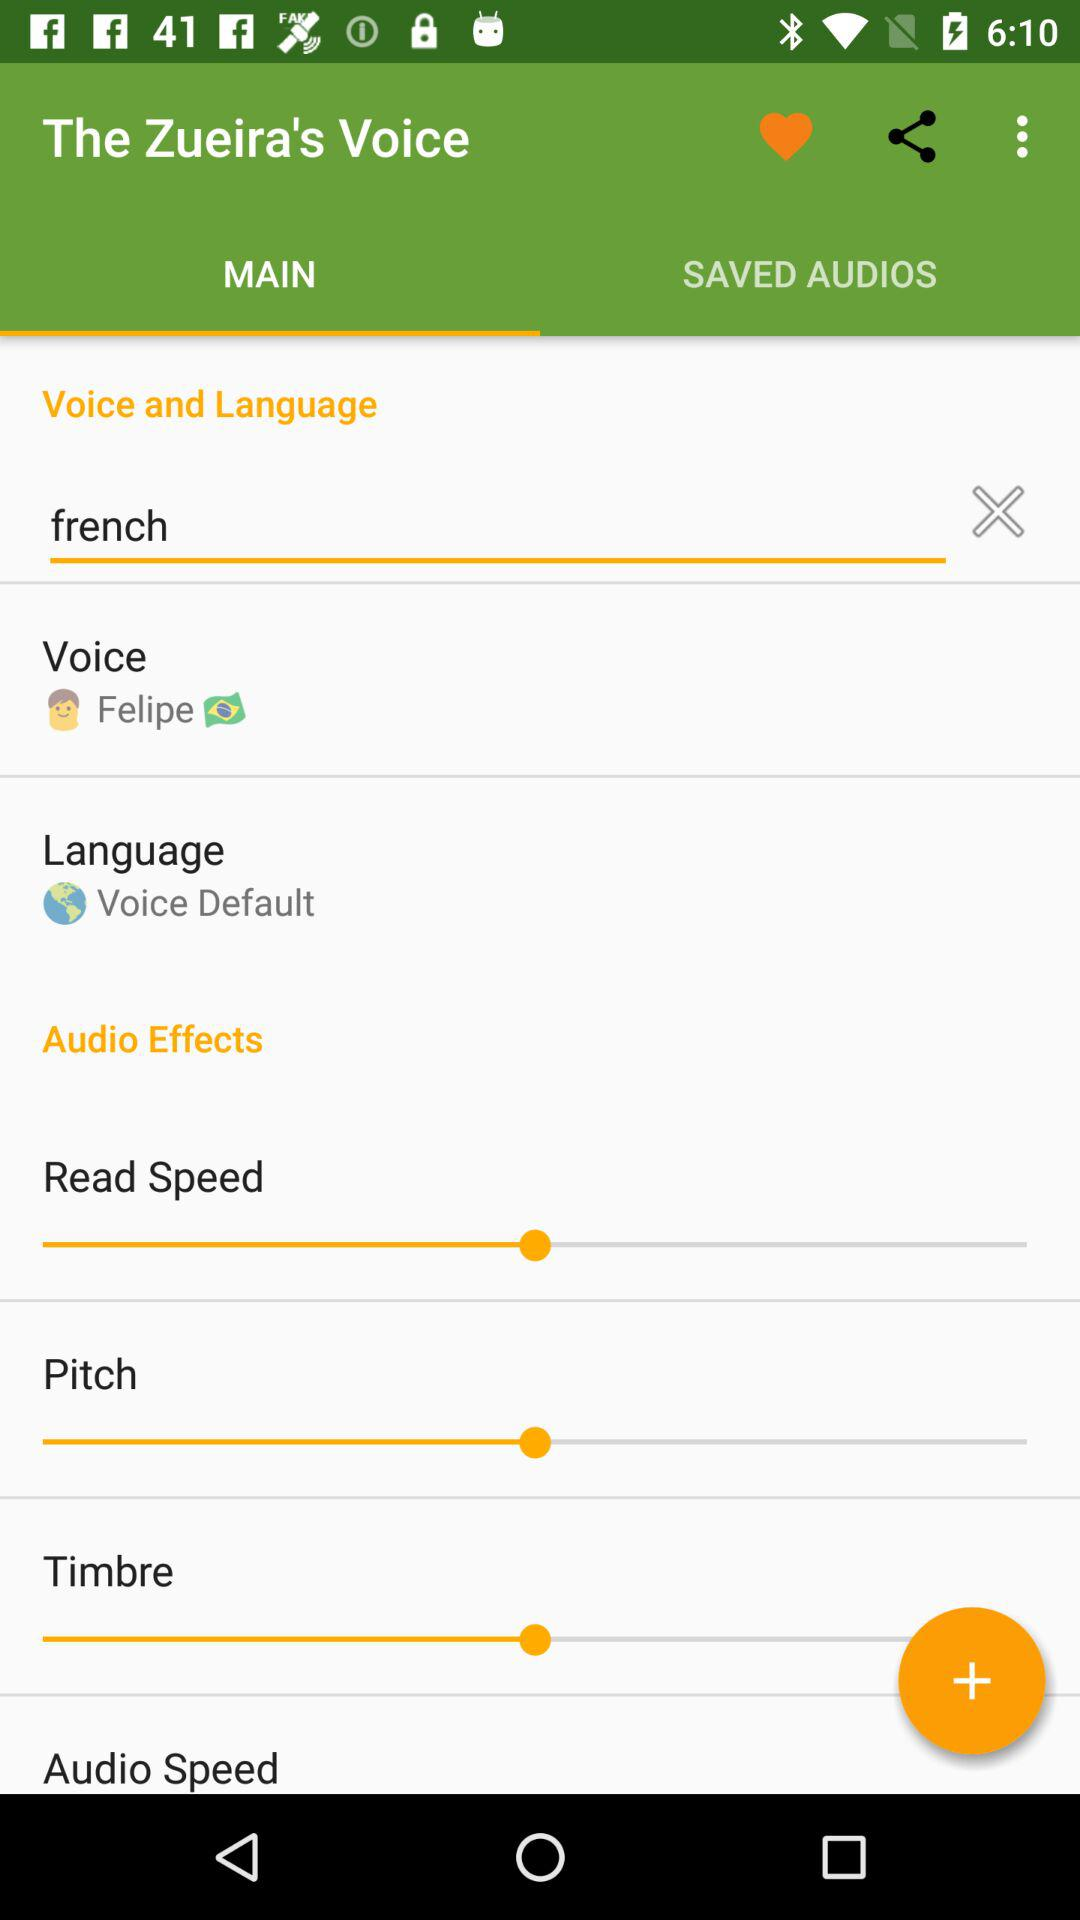What is the app's name? The app's name is "The Zueira's Voice". 